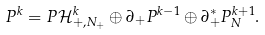<formula> <loc_0><loc_0><loc_500><loc_500>P ^ { k } = P \mathcal { H } _ { + , N _ { + } } ^ { k } \oplus \partial _ { + } P ^ { k - 1 } \oplus \partial _ { + } ^ { \ast } P _ { N } ^ { k + 1 } .</formula> 